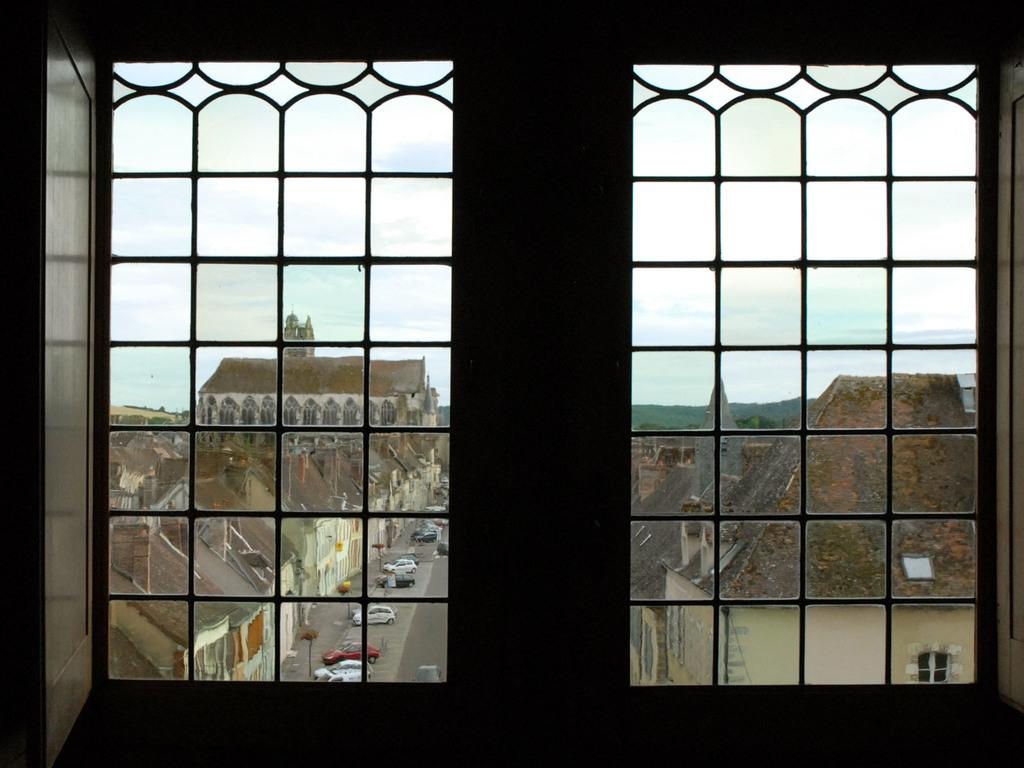What can be seen through the window in the image? A group of buildings and vehicles are visible through the window in the image. What else is visible in the background of the image? There are trees in the background of the image. What is visible at the top of the image? The sky is visible at the top of the image. How many turkeys are tied in a knot in the image? There are no turkeys or knots present in the image. 